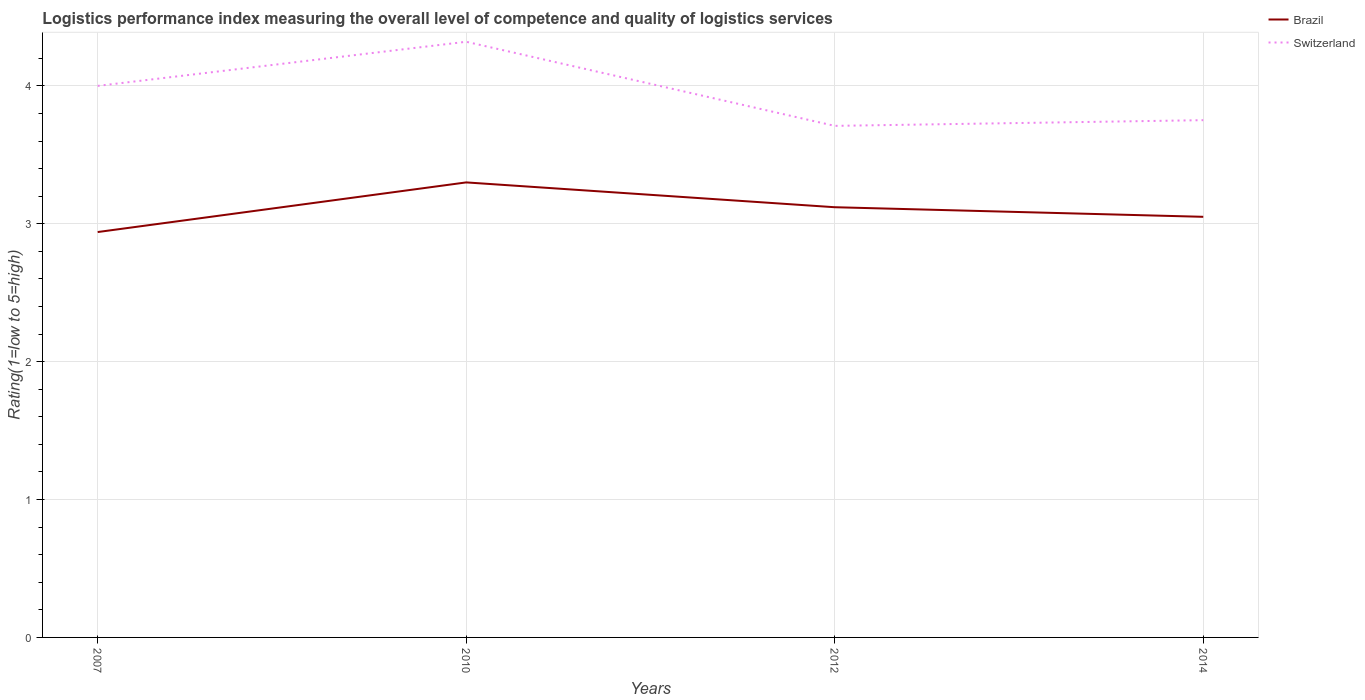Does the line corresponding to Switzerland intersect with the line corresponding to Brazil?
Make the answer very short. No. Across all years, what is the maximum Logistic performance index in Switzerland?
Your response must be concise. 3.71. In which year was the Logistic performance index in Switzerland maximum?
Your response must be concise. 2012. What is the total Logistic performance index in Switzerland in the graph?
Offer a very short reply. 0.57. What is the difference between the highest and the second highest Logistic performance index in Switzerland?
Ensure brevity in your answer.  0.61. Is the Logistic performance index in Brazil strictly greater than the Logistic performance index in Switzerland over the years?
Ensure brevity in your answer.  Yes. How many lines are there?
Your answer should be compact. 2. How many years are there in the graph?
Ensure brevity in your answer.  4. Are the values on the major ticks of Y-axis written in scientific E-notation?
Keep it short and to the point. No. Does the graph contain grids?
Your answer should be very brief. Yes. Where does the legend appear in the graph?
Your answer should be very brief. Top right. How are the legend labels stacked?
Your answer should be very brief. Vertical. What is the title of the graph?
Your answer should be very brief. Logistics performance index measuring the overall level of competence and quality of logistics services. What is the label or title of the Y-axis?
Offer a terse response. Rating(1=low to 5=high). What is the Rating(1=low to 5=high) of Brazil in 2007?
Your answer should be compact. 2.94. What is the Rating(1=low to 5=high) in Brazil in 2010?
Your response must be concise. 3.3. What is the Rating(1=low to 5=high) of Switzerland in 2010?
Your answer should be very brief. 4.32. What is the Rating(1=low to 5=high) of Brazil in 2012?
Give a very brief answer. 3.12. What is the Rating(1=low to 5=high) of Switzerland in 2012?
Provide a succinct answer. 3.71. What is the Rating(1=low to 5=high) of Brazil in 2014?
Your answer should be very brief. 3.05. What is the Rating(1=low to 5=high) in Switzerland in 2014?
Your answer should be very brief. 3.75. Across all years, what is the maximum Rating(1=low to 5=high) in Switzerland?
Offer a very short reply. 4.32. Across all years, what is the minimum Rating(1=low to 5=high) of Brazil?
Your answer should be compact. 2.94. Across all years, what is the minimum Rating(1=low to 5=high) in Switzerland?
Your response must be concise. 3.71. What is the total Rating(1=low to 5=high) in Brazil in the graph?
Provide a short and direct response. 12.41. What is the total Rating(1=low to 5=high) in Switzerland in the graph?
Provide a succinct answer. 15.78. What is the difference between the Rating(1=low to 5=high) in Brazil in 2007 and that in 2010?
Provide a succinct answer. -0.36. What is the difference between the Rating(1=low to 5=high) of Switzerland in 2007 and that in 2010?
Give a very brief answer. -0.32. What is the difference between the Rating(1=low to 5=high) in Brazil in 2007 and that in 2012?
Provide a short and direct response. -0.18. What is the difference between the Rating(1=low to 5=high) of Switzerland in 2007 and that in 2012?
Your response must be concise. 0.29. What is the difference between the Rating(1=low to 5=high) of Brazil in 2007 and that in 2014?
Offer a terse response. -0.11. What is the difference between the Rating(1=low to 5=high) in Switzerland in 2007 and that in 2014?
Provide a succinct answer. 0.25. What is the difference between the Rating(1=low to 5=high) in Brazil in 2010 and that in 2012?
Your answer should be compact. 0.18. What is the difference between the Rating(1=low to 5=high) in Switzerland in 2010 and that in 2012?
Provide a succinct answer. 0.61. What is the difference between the Rating(1=low to 5=high) of Brazil in 2010 and that in 2014?
Offer a very short reply. 0.25. What is the difference between the Rating(1=low to 5=high) of Switzerland in 2010 and that in 2014?
Your answer should be compact. 0.57. What is the difference between the Rating(1=low to 5=high) in Brazil in 2012 and that in 2014?
Give a very brief answer. 0.07. What is the difference between the Rating(1=low to 5=high) of Switzerland in 2012 and that in 2014?
Provide a short and direct response. -0.04. What is the difference between the Rating(1=low to 5=high) of Brazil in 2007 and the Rating(1=low to 5=high) of Switzerland in 2010?
Offer a terse response. -1.38. What is the difference between the Rating(1=low to 5=high) of Brazil in 2007 and the Rating(1=low to 5=high) of Switzerland in 2012?
Ensure brevity in your answer.  -0.77. What is the difference between the Rating(1=low to 5=high) of Brazil in 2007 and the Rating(1=low to 5=high) of Switzerland in 2014?
Provide a short and direct response. -0.81. What is the difference between the Rating(1=low to 5=high) in Brazil in 2010 and the Rating(1=low to 5=high) in Switzerland in 2012?
Make the answer very short. -0.41. What is the difference between the Rating(1=low to 5=high) in Brazil in 2010 and the Rating(1=low to 5=high) in Switzerland in 2014?
Your answer should be compact. -0.45. What is the difference between the Rating(1=low to 5=high) in Brazil in 2012 and the Rating(1=low to 5=high) in Switzerland in 2014?
Make the answer very short. -0.63. What is the average Rating(1=low to 5=high) in Brazil per year?
Your answer should be very brief. 3.1. What is the average Rating(1=low to 5=high) of Switzerland per year?
Your response must be concise. 3.95. In the year 2007, what is the difference between the Rating(1=low to 5=high) in Brazil and Rating(1=low to 5=high) in Switzerland?
Ensure brevity in your answer.  -1.06. In the year 2010, what is the difference between the Rating(1=low to 5=high) in Brazil and Rating(1=low to 5=high) in Switzerland?
Your answer should be very brief. -1.02. In the year 2012, what is the difference between the Rating(1=low to 5=high) in Brazil and Rating(1=low to 5=high) in Switzerland?
Make the answer very short. -0.59. In the year 2014, what is the difference between the Rating(1=low to 5=high) of Brazil and Rating(1=low to 5=high) of Switzerland?
Give a very brief answer. -0.7. What is the ratio of the Rating(1=low to 5=high) in Brazil in 2007 to that in 2010?
Keep it short and to the point. 0.89. What is the ratio of the Rating(1=low to 5=high) in Switzerland in 2007 to that in 2010?
Your answer should be very brief. 0.93. What is the ratio of the Rating(1=low to 5=high) of Brazil in 2007 to that in 2012?
Your response must be concise. 0.94. What is the ratio of the Rating(1=low to 5=high) in Switzerland in 2007 to that in 2012?
Make the answer very short. 1.08. What is the ratio of the Rating(1=low to 5=high) in Brazil in 2007 to that in 2014?
Ensure brevity in your answer.  0.96. What is the ratio of the Rating(1=low to 5=high) of Switzerland in 2007 to that in 2014?
Provide a succinct answer. 1.07. What is the ratio of the Rating(1=low to 5=high) in Brazil in 2010 to that in 2012?
Keep it short and to the point. 1.06. What is the ratio of the Rating(1=low to 5=high) of Switzerland in 2010 to that in 2012?
Offer a terse response. 1.16. What is the ratio of the Rating(1=low to 5=high) of Brazil in 2010 to that in 2014?
Offer a terse response. 1.08. What is the ratio of the Rating(1=low to 5=high) of Switzerland in 2010 to that in 2014?
Ensure brevity in your answer.  1.15. What is the ratio of the Rating(1=low to 5=high) of Brazil in 2012 to that in 2014?
Your response must be concise. 1.02. What is the ratio of the Rating(1=low to 5=high) of Switzerland in 2012 to that in 2014?
Your answer should be very brief. 0.99. What is the difference between the highest and the second highest Rating(1=low to 5=high) in Brazil?
Offer a terse response. 0.18. What is the difference between the highest and the second highest Rating(1=low to 5=high) of Switzerland?
Keep it short and to the point. 0.32. What is the difference between the highest and the lowest Rating(1=low to 5=high) of Brazil?
Your answer should be very brief. 0.36. What is the difference between the highest and the lowest Rating(1=low to 5=high) in Switzerland?
Your answer should be compact. 0.61. 